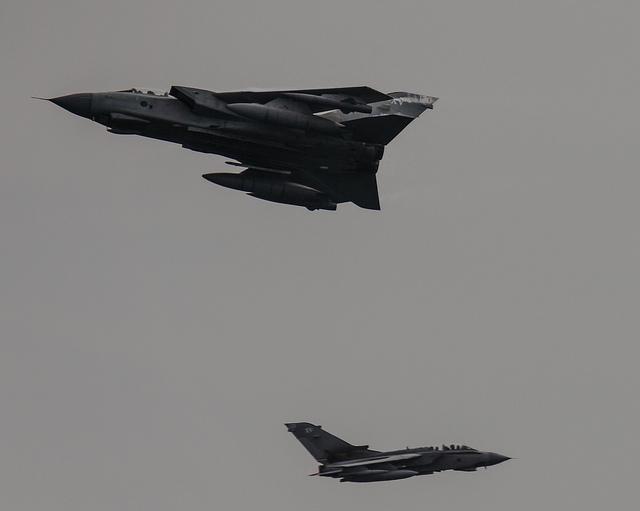How many planes are there?
Give a very brief answer. 2. How many airplanes are there?
Give a very brief answer. 2. 